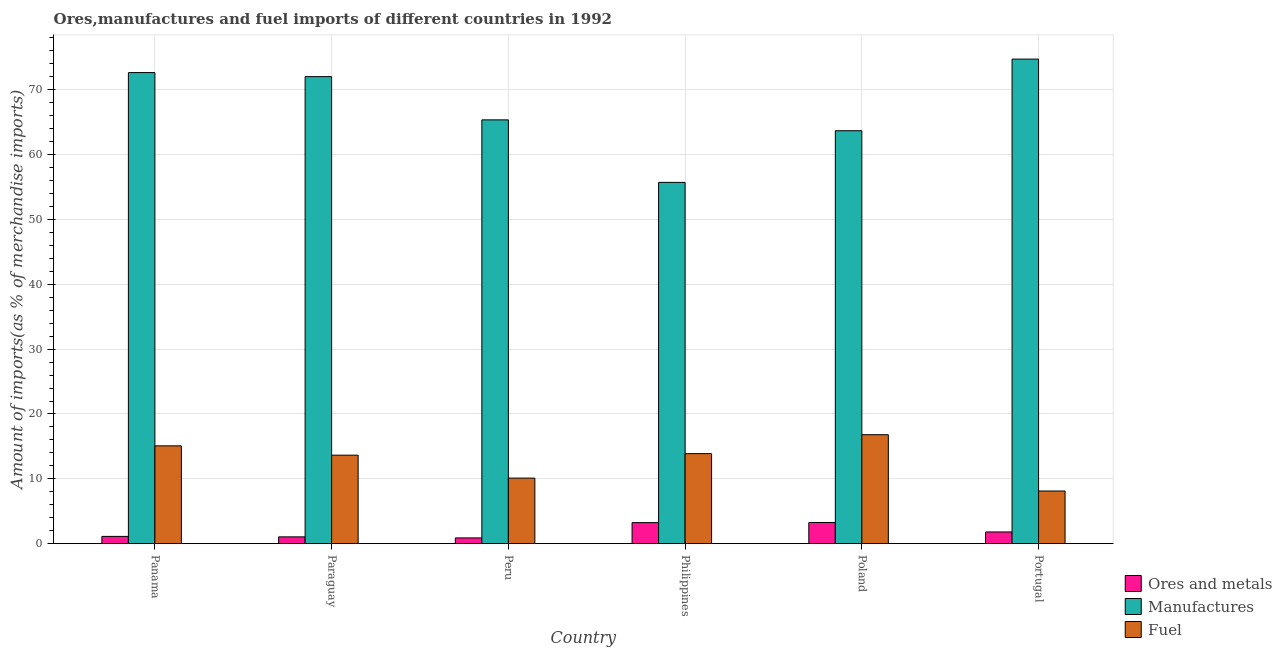How many different coloured bars are there?
Your answer should be compact. 3. How many bars are there on the 6th tick from the left?
Your answer should be compact. 3. How many bars are there on the 1st tick from the right?
Your response must be concise. 3. What is the label of the 4th group of bars from the left?
Your answer should be very brief. Philippines. What is the percentage of manufactures imports in Poland?
Ensure brevity in your answer.  63.69. Across all countries, what is the maximum percentage of ores and metals imports?
Your answer should be compact. 3.27. Across all countries, what is the minimum percentage of ores and metals imports?
Your answer should be very brief. 0.89. In which country was the percentage of manufactures imports maximum?
Your response must be concise. Portugal. In which country was the percentage of manufactures imports minimum?
Your answer should be compact. Philippines. What is the total percentage of fuel imports in the graph?
Provide a short and direct response. 77.65. What is the difference between the percentage of fuel imports in Peru and that in Poland?
Provide a short and direct response. -6.69. What is the difference between the percentage of ores and metals imports in Portugal and the percentage of fuel imports in Poland?
Provide a short and direct response. -15. What is the average percentage of ores and metals imports per country?
Your answer should be very brief. 1.9. What is the difference between the percentage of fuel imports and percentage of ores and metals imports in Paraguay?
Offer a very short reply. 12.6. In how many countries, is the percentage of manufactures imports greater than 10 %?
Your answer should be very brief. 6. What is the ratio of the percentage of fuel imports in Panama to that in Portugal?
Provide a short and direct response. 1.86. Is the percentage of manufactures imports in Panama less than that in Paraguay?
Offer a very short reply. No. What is the difference between the highest and the second highest percentage of fuel imports?
Keep it short and to the point. 1.72. What is the difference between the highest and the lowest percentage of ores and metals imports?
Ensure brevity in your answer.  2.38. In how many countries, is the percentage of fuel imports greater than the average percentage of fuel imports taken over all countries?
Keep it short and to the point. 4. Is the sum of the percentage of fuel imports in Paraguay and Peru greater than the maximum percentage of manufactures imports across all countries?
Your response must be concise. No. What does the 2nd bar from the left in Peru represents?
Provide a short and direct response. Manufactures. What does the 2nd bar from the right in Peru represents?
Offer a terse response. Manufactures. How many countries are there in the graph?
Your response must be concise. 6. What is the difference between two consecutive major ticks on the Y-axis?
Ensure brevity in your answer.  10. Are the values on the major ticks of Y-axis written in scientific E-notation?
Offer a very short reply. No. Where does the legend appear in the graph?
Your answer should be compact. Bottom right. How many legend labels are there?
Your response must be concise. 3. How are the legend labels stacked?
Provide a short and direct response. Vertical. What is the title of the graph?
Provide a short and direct response. Ores,manufactures and fuel imports of different countries in 1992. Does "Oil sources" appear as one of the legend labels in the graph?
Provide a succinct answer. No. What is the label or title of the Y-axis?
Give a very brief answer. Amount of imports(as % of merchandise imports). What is the Amount of imports(as % of merchandise imports) in Ores and metals in Panama?
Ensure brevity in your answer.  1.12. What is the Amount of imports(as % of merchandise imports) of Manufactures in Panama?
Your answer should be very brief. 72.65. What is the Amount of imports(as % of merchandise imports) of Fuel in Panama?
Offer a very short reply. 15.09. What is the Amount of imports(as % of merchandise imports) in Ores and metals in Paraguay?
Your response must be concise. 1.05. What is the Amount of imports(as % of merchandise imports) of Manufactures in Paraguay?
Keep it short and to the point. 72.03. What is the Amount of imports(as % of merchandise imports) of Fuel in Paraguay?
Ensure brevity in your answer.  13.65. What is the Amount of imports(as % of merchandise imports) in Ores and metals in Peru?
Your answer should be compact. 0.89. What is the Amount of imports(as % of merchandise imports) in Manufactures in Peru?
Provide a succinct answer. 65.36. What is the Amount of imports(as % of merchandise imports) in Fuel in Peru?
Ensure brevity in your answer.  10.11. What is the Amount of imports(as % of merchandise imports) of Ores and metals in Philippines?
Give a very brief answer. 3.25. What is the Amount of imports(as % of merchandise imports) in Manufactures in Philippines?
Keep it short and to the point. 55.72. What is the Amount of imports(as % of merchandise imports) of Fuel in Philippines?
Provide a succinct answer. 13.89. What is the Amount of imports(as % of merchandise imports) in Ores and metals in Poland?
Offer a very short reply. 3.27. What is the Amount of imports(as % of merchandise imports) of Manufactures in Poland?
Your response must be concise. 63.69. What is the Amount of imports(as % of merchandise imports) of Fuel in Poland?
Offer a terse response. 16.8. What is the Amount of imports(as % of merchandise imports) in Ores and metals in Portugal?
Keep it short and to the point. 1.81. What is the Amount of imports(as % of merchandise imports) in Manufactures in Portugal?
Your answer should be compact. 74.73. What is the Amount of imports(as % of merchandise imports) of Fuel in Portugal?
Give a very brief answer. 8.12. Across all countries, what is the maximum Amount of imports(as % of merchandise imports) of Ores and metals?
Your answer should be compact. 3.27. Across all countries, what is the maximum Amount of imports(as % of merchandise imports) in Manufactures?
Your response must be concise. 74.73. Across all countries, what is the maximum Amount of imports(as % of merchandise imports) in Fuel?
Keep it short and to the point. 16.8. Across all countries, what is the minimum Amount of imports(as % of merchandise imports) in Ores and metals?
Your answer should be compact. 0.89. Across all countries, what is the minimum Amount of imports(as % of merchandise imports) in Manufactures?
Give a very brief answer. 55.72. Across all countries, what is the minimum Amount of imports(as % of merchandise imports) in Fuel?
Ensure brevity in your answer.  8.12. What is the total Amount of imports(as % of merchandise imports) in Ores and metals in the graph?
Provide a succinct answer. 11.37. What is the total Amount of imports(as % of merchandise imports) of Manufactures in the graph?
Ensure brevity in your answer.  404.19. What is the total Amount of imports(as % of merchandise imports) in Fuel in the graph?
Give a very brief answer. 77.65. What is the difference between the Amount of imports(as % of merchandise imports) in Ores and metals in Panama and that in Paraguay?
Give a very brief answer. 0.07. What is the difference between the Amount of imports(as % of merchandise imports) in Manufactures in Panama and that in Paraguay?
Provide a succinct answer. 0.62. What is the difference between the Amount of imports(as % of merchandise imports) in Fuel in Panama and that in Paraguay?
Offer a very short reply. 1.44. What is the difference between the Amount of imports(as % of merchandise imports) in Ores and metals in Panama and that in Peru?
Offer a very short reply. 0.23. What is the difference between the Amount of imports(as % of merchandise imports) of Manufactures in Panama and that in Peru?
Offer a terse response. 7.29. What is the difference between the Amount of imports(as % of merchandise imports) in Fuel in Panama and that in Peru?
Your answer should be very brief. 4.97. What is the difference between the Amount of imports(as % of merchandise imports) of Ores and metals in Panama and that in Philippines?
Offer a very short reply. -2.13. What is the difference between the Amount of imports(as % of merchandise imports) in Manufactures in Panama and that in Philippines?
Make the answer very short. 16.93. What is the difference between the Amount of imports(as % of merchandise imports) of Fuel in Panama and that in Philippines?
Provide a short and direct response. 1.2. What is the difference between the Amount of imports(as % of merchandise imports) in Ores and metals in Panama and that in Poland?
Provide a succinct answer. -2.15. What is the difference between the Amount of imports(as % of merchandise imports) of Manufactures in Panama and that in Poland?
Your answer should be very brief. 8.97. What is the difference between the Amount of imports(as % of merchandise imports) in Fuel in Panama and that in Poland?
Offer a very short reply. -1.72. What is the difference between the Amount of imports(as % of merchandise imports) in Ores and metals in Panama and that in Portugal?
Make the answer very short. -0.69. What is the difference between the Amount of imports(as % of merchandise imports) of Manufactures in Panama and that in Portugal?
Give a very brief answer. -2.08. What is the difference between the Amount of imports(as % of merchandise imports) in Fuel in Panama and that in Portugal?
Give a very brief answer. 6.96. What is the difference between the Amount of imports(as % of merchandise imports) of Ores and metals in Paraguay and that in Peru?
Provide a short and direct response. 0.16. What is the difference between the Amount of imports(as % of merchandise imports) of Manufactures in Paraguay and that in Peru?
Your answer should be compact. 6.67. What is the difference between the Amount of imports(as % of merchandise imports) in Fuel in Paraguay and that in Peru?
Offer a terse response. 3.54. What is the difference between the Amount of imports(as % of merchandise imports) in Ores and metals in Paraguay and that in Philippines?
Provide a succinct answer. -2.2. What is the difference between the Amount of imports(as % of merchandise imports) of Manufactures in Paraguay and that in Philippines?
Ensure brevity in your answer.  16.31. What is the difference between the Amount of imports(as % of merchandise imports) of Fuel in Paraguay and that in Philippines?
Give a very brief answer. -0.24. What is the difference between the Amount of imports(as % of merchandise imports) of Ores and metals in Paraguay and that in Poland?
Offer a terse response. -2.22. What is the difference between the Amount of imports(as % of merchandise imports) of Manufactures in Paraguay and that in Poland?
Make the answer very short. 8.34. What is the difference between the Amount of imports(as % of merchandise imports) in Fuel in Paraguay and that in Poland?
Ensure brevity in your answer.  -3.15. What is the difference between the Amount of imports(as % of merchandise imports) in Ores and metals in Paraguay and that in Portugal?
Keep it short and to the point. -0.76. What is the difference between the Amount of imports(as % of merchandise imports) in Manufactures in Paraguay and that in Portugal?
Provide a succinct answer. -2.7. What is the difference between the Amount of imports(as % of merchandise imports) in Fuel in Paraguay and that in Portugal?
Your answer should be compact. 5.53. What is the difference between the Amount of imports(as % of merchandise imports) of Ores and metals in Peru and that in Philippines?
Offer a terse response. -2.36. What is the difference between the Amount of imports(as % of merchandise imports) in Manufactures in Peru and that in Philippines?
Keep it short and to the point. 9.64. What is the difference between the Amount of imports(as % of merchandise imports) in Fuel in Peru and that in Philippines?
Your answer should be very brief. -3.77. What is the difference between the Amount of imports(as % of merchandise imports) in Ores and metals in Peru and that in Poland?
Provide a succinct answer. -2.38. What is the difference between the Amount of imports(as % of merchandise imports) in Manufactures in Peru and that in Poland?
Offer a very short reply. 1.67. What is the difference between the Amount of imports(as % of merchandise imports) in Fuel in Peru and that in Poland?
Keep it short and to the point. -6.69. What is the difference between the Amount of imports(as % of merchandise imports) of Ores and metals in Peru and that in Portugal?
Make the answer very short. -0.92. What is the difference between the Amount of imports(as % of merchandise imports) of Manufactures in Peru and that in Portugal?
Your answer should be compact. -9.37. What is the difference between the Amount of imports(as % of merchandise imports) of Fuel in Peru and that in Portugal?
Provide a succinct answer. 1.99. What is the difference between the Amount of imports(as % of merchandise imports) of Ores and metals in Philippines and that in Poland?
Your response must be concise. -0.02. What is the difference between the Amount of imports(as % of merchandise imports) of Manufactures in Philippines and that in Poland?
Offer a terse response. -7.97. What is the difference between the Amount of imports(as % of merchandise imports) of Fuel in Philippines and that in Poland?
Offer a very short reply. -2.92. What is the difference between the Amount of imports(as % of merchandise imports) of Ores and metals in Philippines and that in Portugal?
Provide a succinct answer. 1.44. What is the difference between the Amount of imports(as % of merchandise imports) in Manufactures in Philippines and that in Portugal?
Your response must be concise. -19.01. What is the difference between the Amount of imports(as % of merchandise imports) of Fuel in Philippines and that in Portugal?
Make the answer very short. 5.77. What is the difference between the Amount of imports(as % of merchandise imports) in Ores and metals in Poland and that in Portugal?
Your response must be concise. 1.46. What is the difference between the Amount of imports(as % of merchandise imports) of Manufactures in Poland and that in Portugal?
Provide a short and direct response. -11.05. What is the difference between the Amount of imports(as % of merchandise imports) in Fuel in Poland and that in Portugal?
Keep it short and to the point. 8.68. What is the difference between the Amount of imports(as % of merchandise imports) of Ores and metals in Panama and the Amount of imports(as % of merchandise imports) of Manufactures in Paraguay?
Offer a very short reply. -70.91. What is the difference between the Amount of imports(as % of merchandise imports) in Ores and metals in Panama and the Amount of imports(as % of merchandise imports) in Fuel in Paraguay?
Provide a succinct answer. -12.53. What is the difference between the Amount of imports(as % of merchandise imports) in Manufactures in Panama and the Amount of imports(as % of merchandise imports) in Fuel in Paraguay?
Your answer should be compact. 59.01. What is the difference between the Amount of imports(as % of merchandise imports) in Ores and metals in Panama and the Amount of imports(as % of merchandise imports) in Manufactures in Peru?
Ensure brevity in your answer.  -64.24. What is the difference between the Amount of imports(as % of merchandise imports) of Ores and metals in Panama and the Amount of imports(as % of merchandise imports) of Fuel in Peru?
Your response must be concise. -8.99. What is the difference between the Amount of imports(as % of merchandise imports) of Manufactures in Panama and the Amount of imports(as % of merchandise imports) of Fuel in Peru?
Your answer should be compact. 62.54. What is the difference between the Amount of imports(as % of merchandise imports) in Ores and metals in Panama and the Amount of imports(as % of merchandise imports) in Manufactures in Philippines?
Your response must be concise. -54.6. What is the difference between the Amount of imports(as % of merchandise imports) of Ores and metals in Panama and the Amount of imports(as % of merchandise imports) of Fuel in Philippines?
Your answer should be compact. -12.77. What is the difference between the Amount of imports(as % of merchandise imports) in Manufactures in Panama and the Amount of imports(as % of merchandise imports) in Fuel in Philippines?
Your answer should be compact. 58.77. What is the difference between the Amount of imports(as % of merchandise imports) in Ores and metals in Panama and the Amount of imports(as % of merchandise imports) in Manufactures in Poland?
Your answer should be very brief. -62.57. What is the difference between the Amount of imports(as % of merchandise imports) of Ores and metals in Panama and the Amount of imports(as % of merchandise imports) of Fuel in Poland?
Ensure brevity in your answer.  -15.68. What is the difference between the Amount of imports(as % of merchandise imports) in Manufactures in Panama and the Amount of imports(as % of merchandise imports) in Fuel in Poland?
Provide a succinct answer. 55.85. What is the difference between the Amount of imports(as % of merchandise imports) of Ores and metals in Panama and the Amount of imports(as % of merchandise imports) of Manufactures in Portugal?
Offer a terse response. -73.62. What is the difference between the Amount of imports(as % of merchandise imports) in Ores and metals in Panama and the Amount of imports(as % of merchandise imports) in Fuel in Portugal?
Your response must be concise. -7. What is the difference between the Amount of imports(as % of merchandise imports) of Manufactures in Panama and the Amount of imports(as % of merchandise imports) of Fuel in Portugal?
Ensure brevity in your answer.  64.53. What is the difference between the Amount of imports(as % of merchandise imports) in Ores and metals in Paraguay and the Amount of imports(as % of merchandise imports) in Manufactures in Peru?
Keep it short and to the point. -64.31. What is the difference between the Amount of imports(as % of merchandise imports) in Ores and metals in Paraguay and the Amount of imports(as % of merchandise imports) in Fuel in Peru?
Give a very brief answer. -9.06. What is the difference between the Amount of imports(as % of merchandise imports) of Manufactures in Paraguay and the Amount of imports(as % of merchandise imports) of Fuel in Peru?
Your response must be concise. 61.92. What is the difference between the Amount of imports(as % of merchandise imports) in Ores and metals in Paraguay and the Amount of imports(as % of merchandise imports) in Manufactures in Philippines?
Offer a very short reply. -54.67. What is the difference between the Amount of imports(as % of merchandise imports) of Ores and metals in Paraguay and the Amount of imports(as % of merchandise imports) of Fuel in Philippines?
Offer a very short reply. -12.84. What is the difference between the Amount of imports(as % of merchandise imports) of Manufactures in Paraguay and the Amount of imports(as % of merchandise imports) of Fuel in Philippines?
Provide a succinct answer. 58.14. What is the difference between the Amount of imports(as % of merchandise imports) of Ores and metals in Paraguay and the Amount of imports(as % of merchandise imports) of Manufactures in Poland?
Your answer should be very brief. -62.64. What is the difference between the Amount of imports(as % of merchandise imports) of Ores and metals in Paraguay and the Amount of imports(as % of merchandise imports) of Fuel in Poland?
Offer a terse response. -15.75. What is the difference between the Amount of imports(as % of merchandise imports) of Manufactures in Paraguay and the Amount of imports(as % of merchandise imports) of Fuel in Poland?
Offer a terse response. 55.23. What is the difference between the Amount of imports(as % of merchandise imports) of Ores and metals in Paraguay and the Amount of imports(as % of merchandise imports) of Manufactures in Portugal?
Your answer should be compact. -73.69. What is the difference between the Amount of imports(as % of merchandise imports) of Ores and metals in Paraguay and the Amount of imports(as % of merchandise imports) of Fuel in Portugal?
Provide a short and direct response. -7.07. What is the difference between the Amount of imports(as % of merchandise imports) of Manufactures in Paraguay and the Amount of imports(as % of merchandise imports) of Fuel in Portugal?
Your answer should be compact. 63.91. What is the difference between the Amount of imports(as % of merchandise imports) in Ores and metals in Peru and the Amount of imports(as % of merchandise imports) in Manufactures in Philippines?
Offer a very short reply. -54.83. What is the difference between the Amount of imports(as % of merchandise imports) of Ores and metals in Peru and the Amount of imports(as % of merchandise imports) of Fuel in Philippines?
Offer a very short reply. -13. What is the difference between the Amount of imports(as % of merchandise imports) in Manufactures in Peru and the Amount of imports(as % of merchandise imports) in Fuel in Philippines?
Offer a terse response. 51.48. What is the difference between the Amount of imports(as % of merchandise imports) of Ores and metals in Peru and the Amount of imports(as % of merchandise imports) of Manufactures in Poland?
Give a very brief answer. -62.8. What is the difference between the Amount of imports(as % of merchandise imports) of Ores and metals in Peru and the Amount of imports(as % of merchandise imports) of Fuel in Poland?
Your response must be concise. -15.92. What is the difference between the Amount of imports(as % of merchandise imports) in Manufactures in Peru and the Amount of imports(as % of merchandise imports) in Fuel in Poland?
Your response must be concise. 48.56. What is the difference between the Amount of imports(as % of merchandise imports) in Ores and metals in Peru and the Amount of imports(as % of merchandise imports) in Manufactures in Portugal?
Ensure brevity in your answer.  -73.85. What is the difference between the Amount of imports(as % of merchandise imports) of Ores and metals in Peru and the Amount of imports(as % of merchandise imports) of Fuel in Portugal?
Keep it short and to the point. -7.23. What is the difference between the Amount of imports(as % of merchandise imports) in Manufactures in Peru and the Amount of imports(as % of merchandise imports) in Fuel in Portugal?
Ensure brevity in your answer.  57.24. What is the difference between the Amount of imports(as % of merchandise imports) in Ores and metals in Philippines and the Amount of imports(as % of merchandise imports) in Manufactures in Poland?
Ensure brevity in your answer.  -60.44. What is the difference between the Amount of imports(as % of merchandise imports) of Ores and metals in Philippines and the Amount of imports(as % of merchandise imports) of Fuel in Poland?
Ensure brevity in your answer.  -13.56. What is the difference between the Amount of imports(as % of merchandise imports) of Manufactures in Philippines and the Amount of imports(as % of merchandise imports) of Fuel in Poland?
Your answer should be compact. 38.92. What is the difference between the Amount of imports(as % of merchandise imports) of Ores and metals in Philippines and the Amount of imports(as % of merchandise imports) of Manufactures in Portugal?
Your answer should be very brief. -71.49. What is the difference between the Amount of imports(as % of merchandise imports) in Ores and metals in Philippines and the Amount of imports(as % of merchandise imports) in Fuel in Portugal?
Your answer should be compact. -4.88. What is the difference between the Amount of imports(as % of merchandise imports) of Manufactures in Philippines and the Amount of imports(as % of merchandise imports) of Fuel in Portugal?
Provide a short and direct response. 47.6. What is the difference between the Amount of imports(as % of merchandise imports) of Ores and metals in Poland and the Amount of imports(as % of merchandise imports) of Manufactures in Portugal?
Give a very brief answer. -71.47. What is the difference between the Amount of imports(as % of merchandise imports) of Ores and metals in Poland and the Amount of imports(as % of merchandise imports) of Fuel in Portugal?
Your answer should be compact. -4.85. What is the difference between the Amount of imports(as % of merchandise imports) in Manufactures in Poland and the Amount of imports(as % of merchandise imports) in Fuel in Portugal?
Offer a terse response. 55.57. What is the average Amount of imports(as % of merchandise imports) in Ores and metals per country?
Ensure brevity in your answer.  1.9. What is the average Amount of imports(as % of merchandise imports) of Manufactures per country?
Make the answer very short. 67.37. What is the average Amount of imports(as % of merchandise imports) in Fuel per country?
Provide a succinct answer. 12.94. What is the difference between the Amount of imports(as % of merchandise imports) of Ores and metals and Amount of imports(as % of merchandise imports) of Manufactures in Panama?
Offer a terse response. -71.54. What is the difference between the Amount of imports(as % of merchandise imports) of Ores and metals and Amount of imports(as % of merchandise imports) of Fuel in Panama?
Keep it short and to the point. -13.97. What is the difference between the Amount of imports(as % of merchandise imports) of Manufactures and Amount of imports(as % of merchandise imports) of Fuel in Panama?
Your response must be concise. 57.57. What is the difference between the Amount of imports(as % of merchandise imports) of Ores and metals and Amount of imports(as % of merchandise imports) of Manufactures in Paraguay?
Provide a succinct answer. -70.98. What is the difference between the Amount of imports(as % of merchandise imports) in Ores and metals and Amount of imports(as % of merchandise imports) in Fuel in Paraguay?
Provide a succinct answer. -12.6. What is the difference between the Amount of imports(as % of merchandise imports) in Manufactures and Amount of imports(as % of merchandise imports) in Fuel in Paraguay?
Your response must be concise. 58.38. What is the difference between the Amount of imports(as % of merchandise imports) of Ores and metals and Amount of imports(as % of merchandise imports) of Manufactures in Peru?
Give a very brief answer. -64.48. What is the difference between the Amount of imports(as % of merchandise imports) of Ores and metals and Amount of imports(as % of merchandise imports) of Fuel in Peru?
Give a very brief answer. -9.22. What is the difference between the Amount of imports(as % of merchandise imports) of Manufactures and Amount of imports(as % of merchandise imports) of Fuel in Peru?
Make the answer very short. 55.25. What is the difference between the Amount of imports(as % of merchandise imports) of Ores and metals and Amount of imports(as % of merchandise imports) of Manufactures in Philippines?
Provide a succinct answer. -52.48. What is the difference between the Amount of imports(as % of merchandise imports) in Ores and metals and Amount of imports(as % of merchandise imports) in Fuel in Philippines?
Offer a very short reply. -10.64. What is the difference between the Amount of imports(as % of merchandise imports) in Manufactures and Amount of imports(as % of merchandise imports) in Fuel in Philippines?
Offer a very short reply. 41.84. What is the difference between the Amount of imports(as % of merchandise imports) of Ores and metals and Amount of imports(as % of merchandise imports) of Manufactures in Poland?
Keep it short and to the point. -60.42. What is the difference between the Amount of imports(as % of merchandise imports) of Ores and metals and Amount of imports(as % of merchandise imports) of Fuel in Poland?
Provide a succinct answer. -13.53. What is the difference between the Amount of imports(as % of merchandise imports) in Manufactures and Amount of imports(as % of merchandise imports) in Fuel in Poland?
Give a very brief answer. 46.89. What is the difference between the Amount of imports(as % of merchandise imports) in Ores and metals and Amount of imports(as % of merchandise imports) in Manufactures in Portugal?
Offer a terse response. -72.93. What is the difference between the Amount of imports(as % of merchandise imports) in Ores and metals and Amount of imports(as % of merchandise imports) in Fuel in Portugal?
Offer a very short reply. -6.32. What is the difference between the Amount of imports(as % of merchandise imports) of Manufactures and Amount of imports(as % of merchandise imports) of Fuel in Portugal?
Your answer should be very brief. 66.61. What is the ratio of the Amount of imports(as % of merchandise imports) in Ores and metals in Panama to that in Paraguay?
Your response must be concise. 1.07. What is the ratio of the Amount of imports(as % of merchandise imports) of Manufactures in Panama to that in Paraguay?
Your response must be concise. 1.01. What is the ratio of the Amount of imports(as % of merchandise imports) in Fuel in Panama to that in Paraguay?
Provide a short and direct response. 1.11. What is the ratio of the Amount of imports(as % of merchandise imports) of Ores and metals in Panama to that in Peru?
Ensure brevity in your answer.  1.26. What is the ratio of the Amount of imports(as % of merchandise imports) in Manufactures in Panama to that in Peru?
Ensure brevity in your answer.  1.11. What is the ratio of the Amount of imports(as % of merchandise imports) in Fuel in Panama to that in Peru?
Give a very brief answer. 1.49. What is the ratio of the Amount of imports(as % of merchandise imports) in Ores and metals in Panama to that in Philippines?
Your answer should be very brief. 0.34. What is the ratio of the Amount of imports(as % of merchandise imports) of Manufactures in Panama to that in Philippines?
Offer a very short reply. 1.3. What is the ratio of the Amount of imports(as % of merchandise imports) in Fuel in Panama to that in Philippines?
Ensure brevity in your answer.  1.09. What is the ratio of the Amount of imports(as % of merchandise imports) of Ores and metals in Panama to that in Poland?
Offer a terse response. 0.34. What is the ratio of the Amount of imports(as % of merchandise imports) in Manufactures in Panama to that in Poland?
Keep it short and to the point. 1.14. What is the ratio of the Amount of imports(as % of merchandise imports) in Fuel in Panama to that in Poland?
Offer a very short reply. 0.9. What is the ratio of the Amount of imports(as % of merchandise imports) of Ores and metals in Panama to that in Portugal?
Offer a very short reply. 0.62. What is the ratio of the Amount of imports(as % of merchandise imports) of Manufactures in Panama to that in Portugal?
Keep it short and to the point. 0.97. What is the ratio of the Amount of imports(as % of merchandise imports) in Fuel in Panama to that in Portugal?
Your answer should be very brief. 1.86. What is the ratio of the Amount of imports(as % of merchandise imports) of Ores and metals in Paraguay to that in Peru?
Give a very brief answer. 1.18. What is the ratio of the Amount of imports(as % of merchandise imports) of Manufactures in Paraguay to that in Peru?
Make the answer very short. 1.1. What is the ratio of the Amount of imports(as % of merchandise imports) of Fuel in Paraguay to that in Peru?
Your response must be concise. 1.35. What is the ratio of the Amount of imports(as % of merchandise imports) in Ores and metals in Paraguay to that in Philippines?
Offer a very short reply. 0.32. What is the ratio of the Amount of imports(as % of merchandise imports) in Manufactures in Paraguay to that in Philippines?
Offer a terse response. 1.29. What is the ratio of the Amount of imports(as % of merchandise imports) of Fuel in Paraguay to that in Philippines?
Your answer should be very brief. 0.98. What is the ratio of the Amount of imports(as % of merchandise imports) of Ores and metals in Paraguay to that in Poland?
Ensure brevity in your answer.  0.32. What is the ratio of the Amount of imports(as % of merchandise imports) in Manufactures in Paraguay to that in Poland?
Make the answer very short. 1.13. What is the ratio of the Amount of imports(as % of merchandise imports) of Fuel in Paraguay to that in Poland?
Ensure brevity in your answer.  0.81. What is the ratio of the Amount of imports(as % of merchandise imports) in Ores and metals in Paraguay to that in Portugal?
Offer a terse response. 0.58. What is the ratio of the Amount of imports(as % of merchandise imports) of Manufactures in Paraguay to that in Portugal?
Your answer should be compact. 0.96. What is the ratio of the Amount of imports(as % of merchandise imports) of Fuel in Paraguay to that in Portugal?
Offer a very short reply. 1.68. What is the ratio of the Amount of imports(as % of merchandise imports) of Ores and metals in Peru to that in Philippines?
Ensure brevity in your answer.  0.27. What is the ratio of the Amount of imports(as % of merchandise imports) of Manufactures in Peru to that in Philippines?
Ensure brevity in your answer.  1.17. What is the ratio of the Amount of imports(as % of merchandise imports) in Fuel in Peru to that in Philippines?
Keep it short and to the point. 0.73. What is the ratio of the Amount of imports(as % of merchandise imports) in Ores and metals in Peru to that in Poland?
Your response must be concise. 0.27. What is the ratio of the Amount of imports(as % of merchandise imports) in Manufactures in Peru to that in Poland?
Offer a terse response. 1.03. What is the ratio of the Amount of imports(as % of merchandise imports) in Fuel in Peru to that in Poland?
Keep it short and to the point. 0.6. What is the ratio of the Amount of imports(as % of merchandise imports) in Ores and metals in Peru to that in Portugal?
Keep it short and to the point. 0.49. What is the ratio of the Amount of imports(as % of merchandise imports) in Manufactures in Peru to that in Portugal?
Your response must be concise. 0.87. What is the ratio of the Amount of imports(as % of merchandise imports) of Fuel in Peru to that in Portugal?
Give a very brief answer. 1.25. What is the ratio of the Amount of imports(as % of merchandise imports) of Ores and metals in Philippines to that in Poland?
Give a very brief answer. 0.99. What is the ratio of the Amount of imports(as % of merchandise imports) of Manufactures in Philippines to that in Poland?
Your answer should be very brief. 0.87. What is the ratio of the Amount of imports(as % of merchandise imports) in Fuel in Philippines to that in Poland?
Your answer should be very brief. 0.83. What is the ratio of the Amount of imports(as % of merchandise imports) of Ores and metals in Philippines to that in Portugal?
Ensure brevity in your answer.  1.8. What is the ratio of the Amount of imports(as % of merchandise imports) of Manufactures in Philippines to that in Portugal?
Make the answer very short. 0.75. What is the ratio of the Amount of imports(as % of merchandise imports) in Fuel in Philippines to that in Portugal?
Your answer should be compact. 1.71. What is the ratio of the Amount of imports(as % of merchandise imports) in Ores and metals in Poland to that in Portugal?
Keep it short and to the point. 1.81. What is the ratio of the Amount of imports(as % of merchandise imports) in Manufactures in Poland to that in Portugal?
Ensure brevity in your answer.  0.85. What is the ratio of the Amount of imports(as % of merchandise imports) of Fuel in Poland to that in Portugal?
Your answer should be very brief. 2.07. What is the difference between the highest and the second highest Amount of imports(as % of merchandise imports) of Ores and metals?
Keep it short and to the point. 0.02. What is the difference between the highest and the second highest Amount of imports(as % of merchandise imports) of Manufactures?
Provide a short and direct response. 2.08. What is the difference between the highest and the second highest Amount of imports(as % of merchandise imports) of Fuel?
Provide a short and direct response. 1.72. What is the difference between the highest and the lowest Amount of imports(as % of merchandise imports) in Ores and metals?
Your answer should be compact. 2.38. What is the difference between the highest and the lowest Amount of imports(as % of merchandise imports) of Manufactures?
Your answer should be compact. 19.01. What is the difference between the highest and the lowest Amount of imports(as % of merchandise imports) of Fuel?
Ensure brevity in your answer.  8.68. 